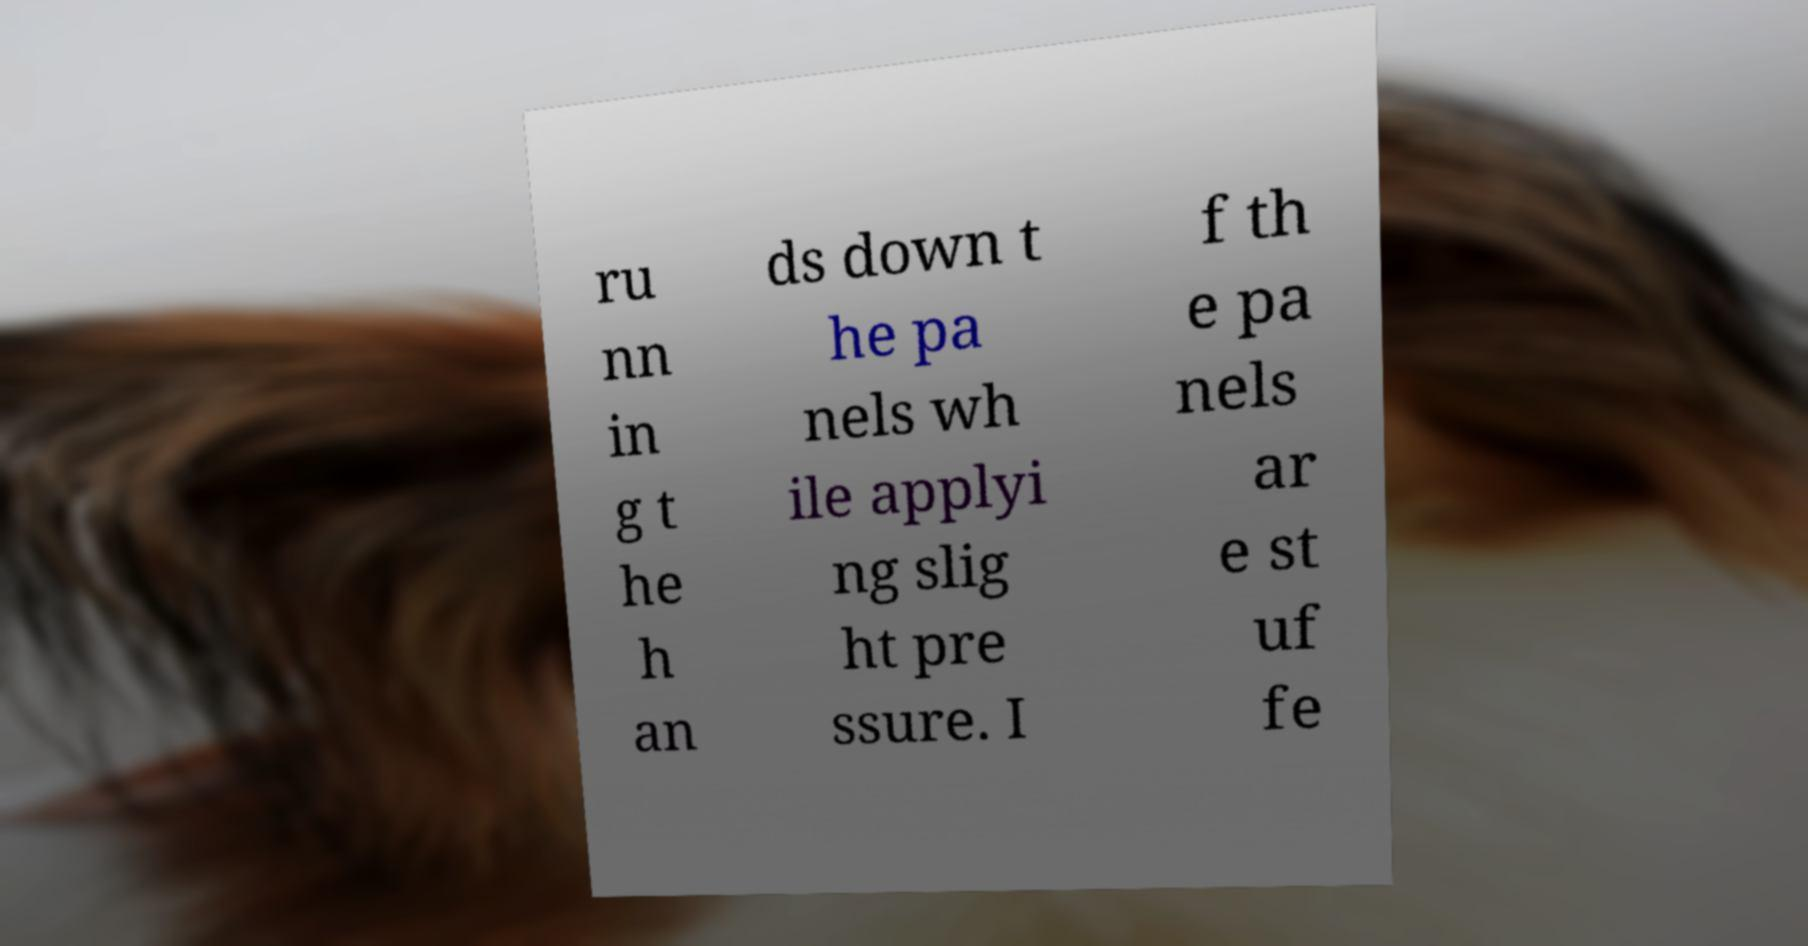Please read and relay the text visible in this image. What does it say? ru nn in g t he h an ds down t he pa nels wh ile applyi ng slig ht pre ssure. I f th e pa nels ar e st uf fe 